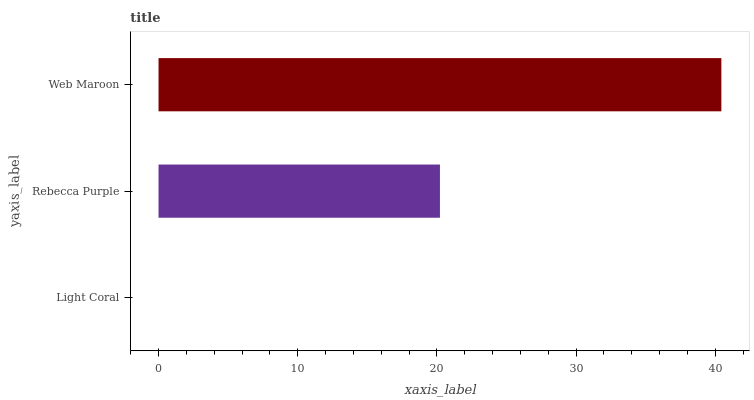Is Light Coral the minimum?
Answer yes or no. Yes. Is Web Maroon the maximum?
Answer yes or no. Yes. Is Rebecca Purple the minimum?
Answer yes or no. No. Is Rebecca Purple the maximum?
Answer yes or no. No. Is Rebecca Purple greater than Light Coral?
Answer yes or no. Yes. Is Light Coral less than Rebecca Purple?
Answer yes or no. Yes. Is Light Coral greater than Rebecca Purple?
Answer yes or no. No. Is Rebecca Purple less than Light Coral?
Answer yes or no. No. Is Rebecca Purple the high median?
Answer yes or no. Yes. Is Rebecca Purple the low median?
Answer yes or no. Yes. Is Web Maroon the high median?
Answer yes or no. No. Is Web Maroon the low median?
Answer yes or no. No. 